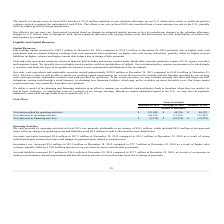According to Formfactor's financial document, What is the increase in accounts payable from December 28, 2019 to December 29, 2018? Based on the financial document, the answer is $0.9 million. Also, can you calculate: What is the change in Net cash provided by operating activities from Fiscal Year Ended December 28, 2019 to December 29, 2018? Based on the calculation: 121,048-68,700, the result is 52348 (in thousands). This is based on the information: "Net cash provided by operating activities $ 121,048 $ 68,700 $ 86,323 cash provided by operating activities $ 121,048 $ 68,700 $ 86,323..." The key data points involved are: 121,048, 68,700. Also, can you calculate: What is the change in Net cash used in investing activities from Fiscal Year Ended December 28, 2019 to December 29, 2018? Based on the calculation: -66,352-(21,295), the result is -45057 (in thousands). This is based on the information: "Net cash used in investing activities (66,352) (21,295) (59,425) Net cash used in investing activities (66,352) (21,295) (59,425)..." The key data points involved are: 21,295, 66,352. Additionally, In which year was Net cash provided by operating activities less than 100,000 thousands? The document shows two values: 2018 and 2017. Locate and analyze net cash provided by operating activities in row 4. From the document: "December 28, 2019 December 29, 2018 December 30, 2017 December 28, 2019 December 29, 2018 December 30, 2017..." Also, What was the net income in 2019? According to the financial document, $39.3 million. The relevant text states: "l 2019 was primarily attributable to net income of $39.3 million, which included $89.9 million of net non-cash items, offset by changes in operating assets and liab..." Also, What was the Net cash used in investing activities in 2019, 2018 and 2017 respectively? The document contains multiple relevant values: (66,352), (21,295), (59,425) (in thousands). From the document: "Net cash used in investing activities (66,352) (21,295) (59,425) ash used in investing activities (66,352) (21,295) (59,425) Net cash used in investin..." 